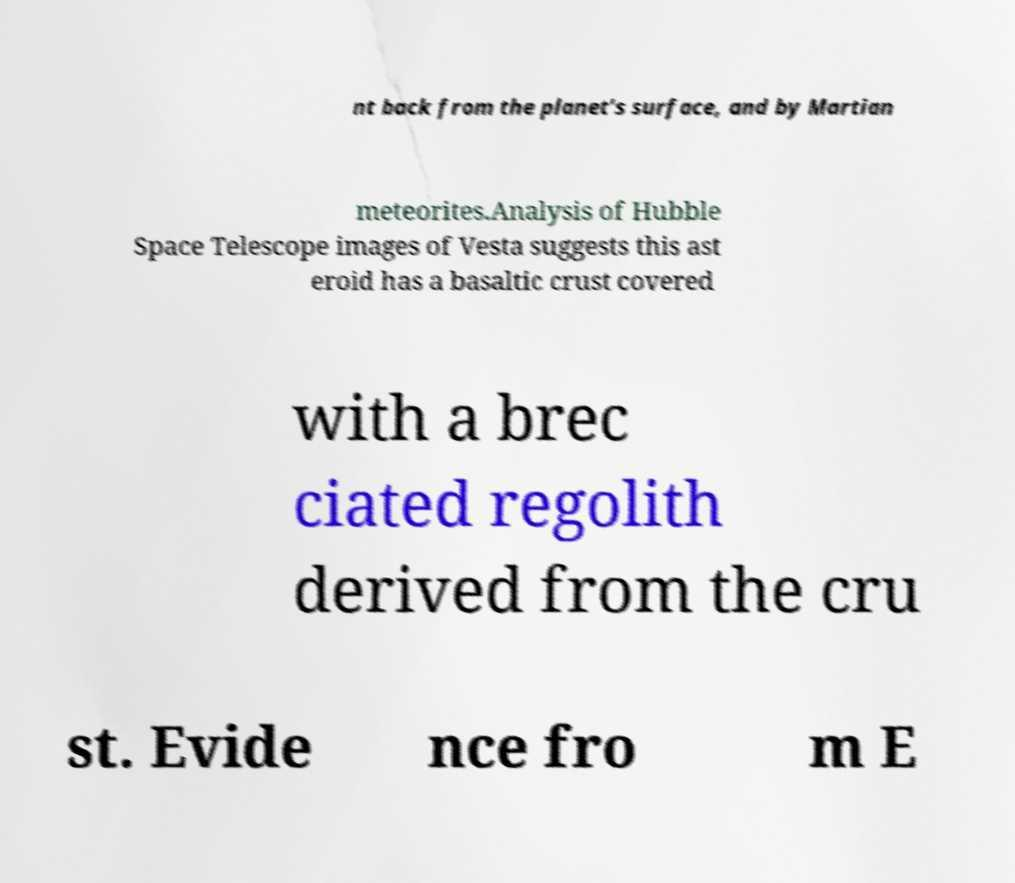Please identify and transcribe the text found in this image. nt back from the planet's surface, and by Martian meteorites.Analysis of Hubble Space Telescope images of Vesta suggests this ast eroid has a basaltic crust covered with a brec ciated regolith derived from the cru st. Evide nce fro m E 